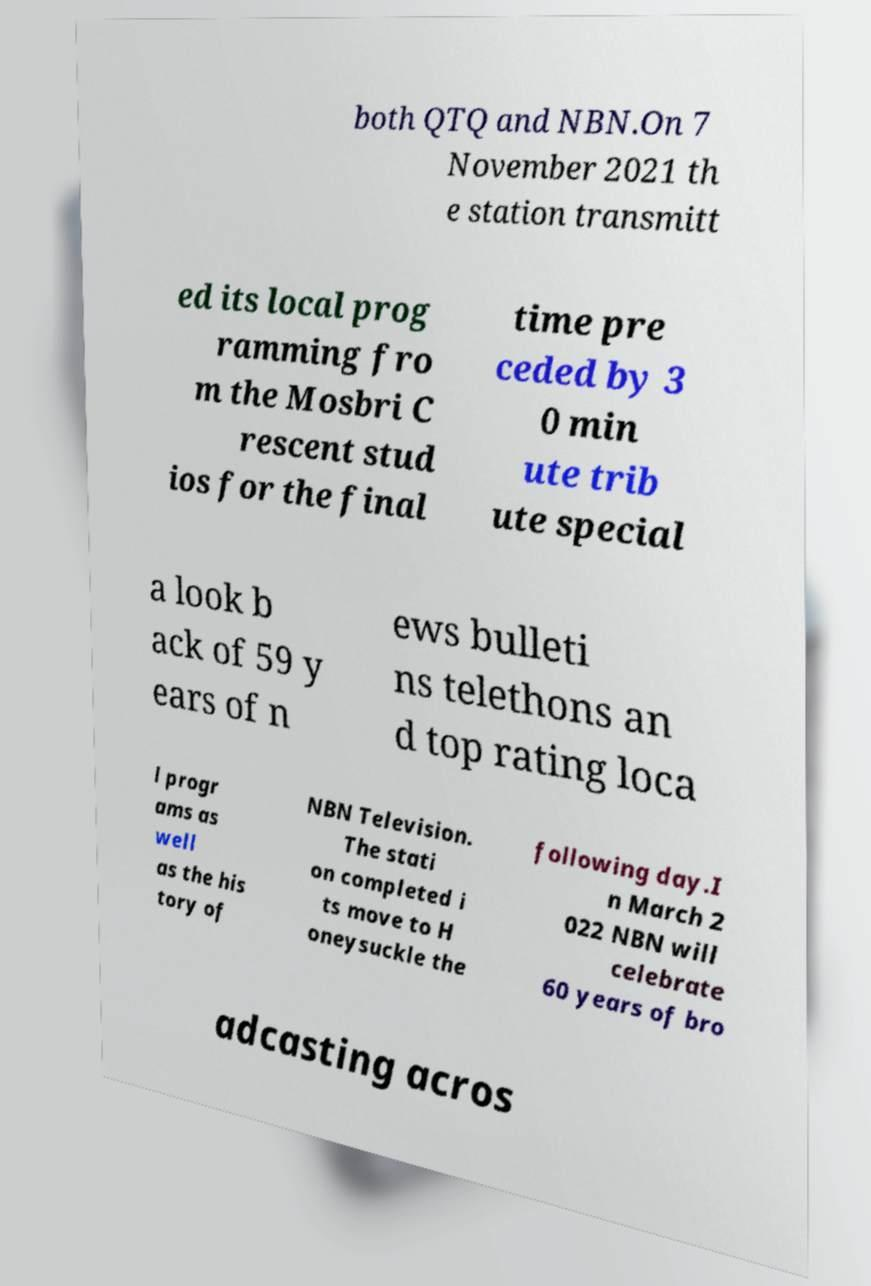Can you accurately transcribe the text from the provided image for me? both QTQ and NBN.On 7 November 2021 th e station transmitt ed its local prog ramming fro m the Mosbri C rescent stud ios for the final time pre ceded by 3 0 min ute trib ute special a look b ack of 59 y ears of n ews bulleti ns telethons an d top rating loca l progr ams as well as the his tory of NBN Television. The stati on completed i ts move to H oneysuckle the following day.I n March 2 022 NBN will celebrate 60 years of bro adcasting acros 